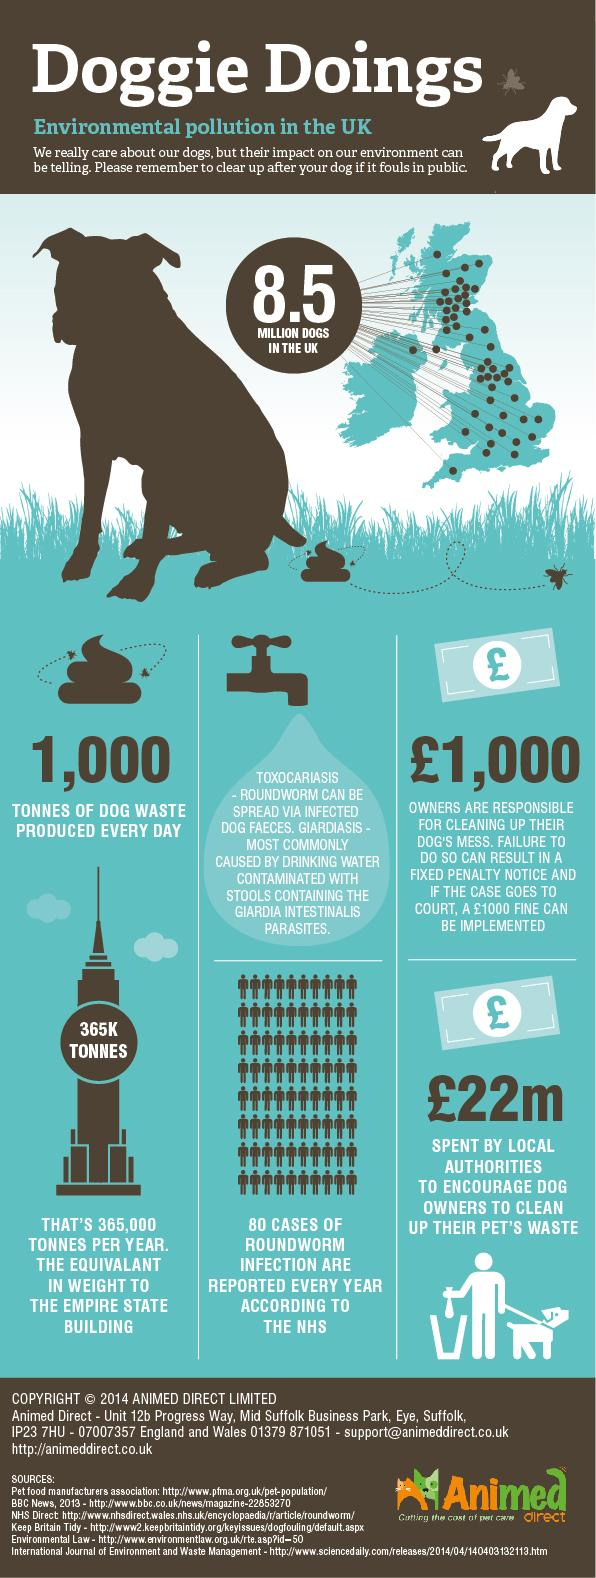Draw attention to some important aspects in this diagram. The Empire State Building is a famous landmark that is mentioned. According to estimates, approximately 80 people are affected by roundworm every year. There are 6 sources listed at the bottom. 